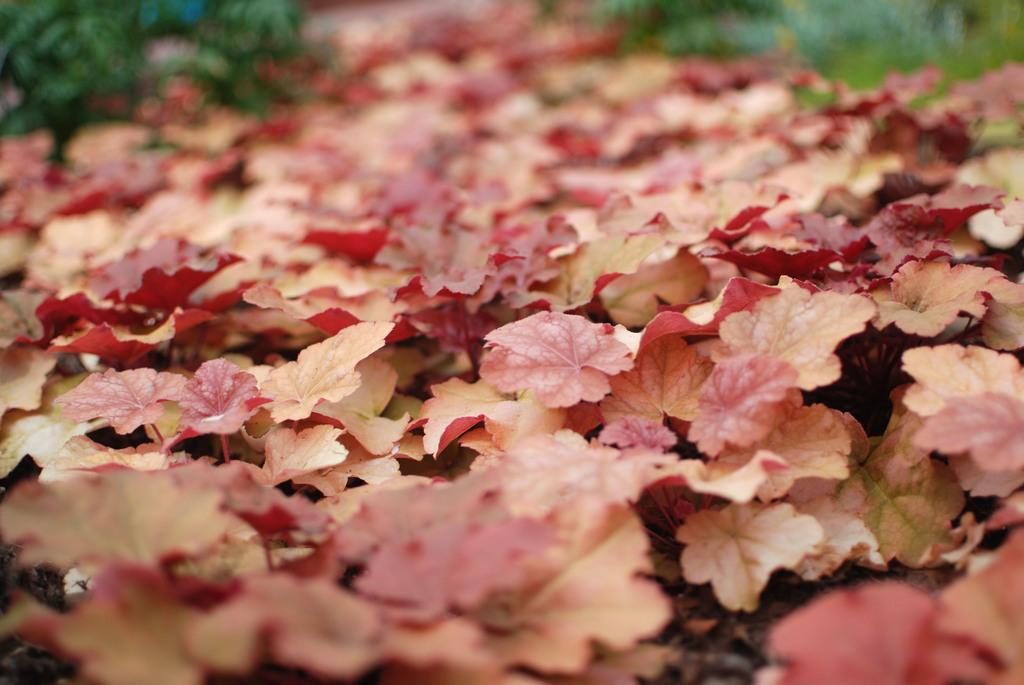What type of living organisms can be seen in the image? Plants can be seen in the image. Can you tell me how many kittens are playing with the wire in the image? There are no kittens or wire present in the image; it only contains plants. 